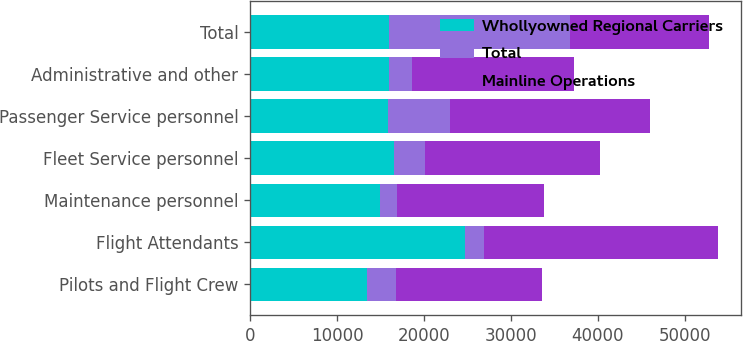Convert chart. <chart><loc_0><loc_0><loc_500><loc_500><stacked_bar_chart><ecel><fcel>Pilots and Flight Crew<fcel>Flight Attendants<fcel>Maintenance personnel<fcel>Fleet Service personnel<fcel>Passenger Service personnel<fcel>Administrative and other<fcel>Total<nl><fcel>Whollyowned Regional Carriers<fcel>13400<fcel>24700<fcel>14900<fcel>16600<fcel>15900<fcel>16000<fcel>16000<nl><fcel>Total<fcel>3400<fcel>2200<fcel>2000<fcel>3500<fcel>7100<fcel>2600<fcel>20800<nl><fcel>Mainline Operations<fcel>16800<fcel>26900<fcel>16900<fcel>20100<fcel>23000<fcel>18600<fcel>16000<nl></chart> 